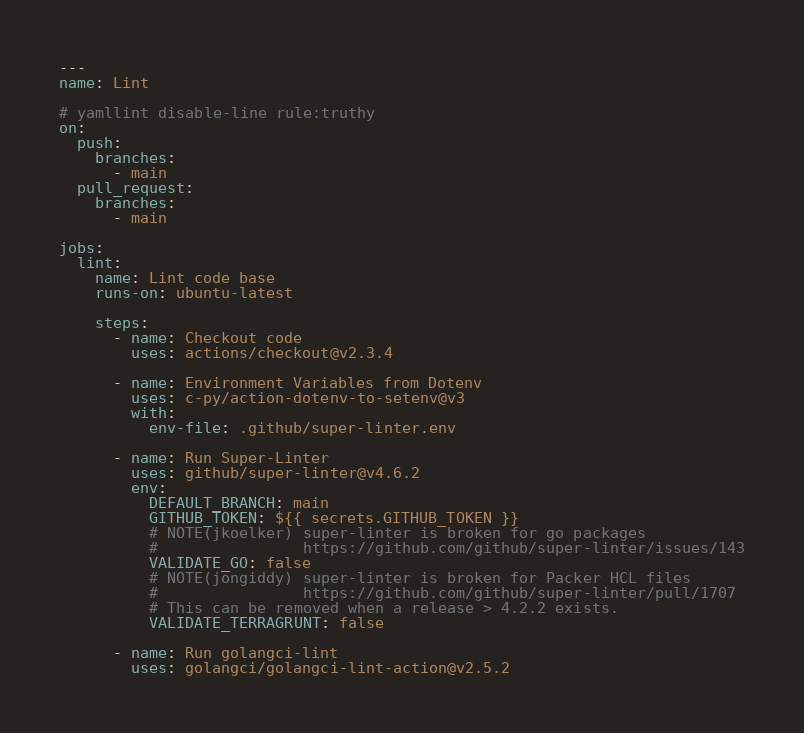Convert code to text. <code><loc_0><loc_0><loc_500><loc_500><_YAML_>---
name: Lint

# yamllint disable-line rule:truthy
on:
  push:
    branches:
      - main
  pull_request:
    branches:
      - main

jobs:
  lint:
    name: Lint code base
    runs-on: ubuntu-latest

    steps:
      - name: Checkout code
        uses: actions/checkout@v2.3.4

      - name: Environment Variables from Dotenv
        uses: c-py/action-dotenv-to-setenv@v3
        with:
          env-file: .github/super-linter.env

      - name: Run Super-Linter
        uses: github/super-linter@v4.6.2
        env:
          DEFAULT_BRANCH: main
          GITHUB_TOKEN: ${{ secrets.GITHUB_TOKEN }}
          # NOTE(jkoelker) super-linter is broken for go packages
          #                https://github.com/github/super-linter/issues/143
          VALIDATE_GO: false
          # NOTE(jongiddy) super-linter is broken for Packer HCL files
          #                https://github.com/github/super-linter/pull/1707
          # This can be removed when a release > 4.2.2 exists.
          VALIDATE_TERRAGRUNT: false

      - name: Run golangci-lint
        uses: golangci/golangci-lint-action@v2.5.2
</code> 